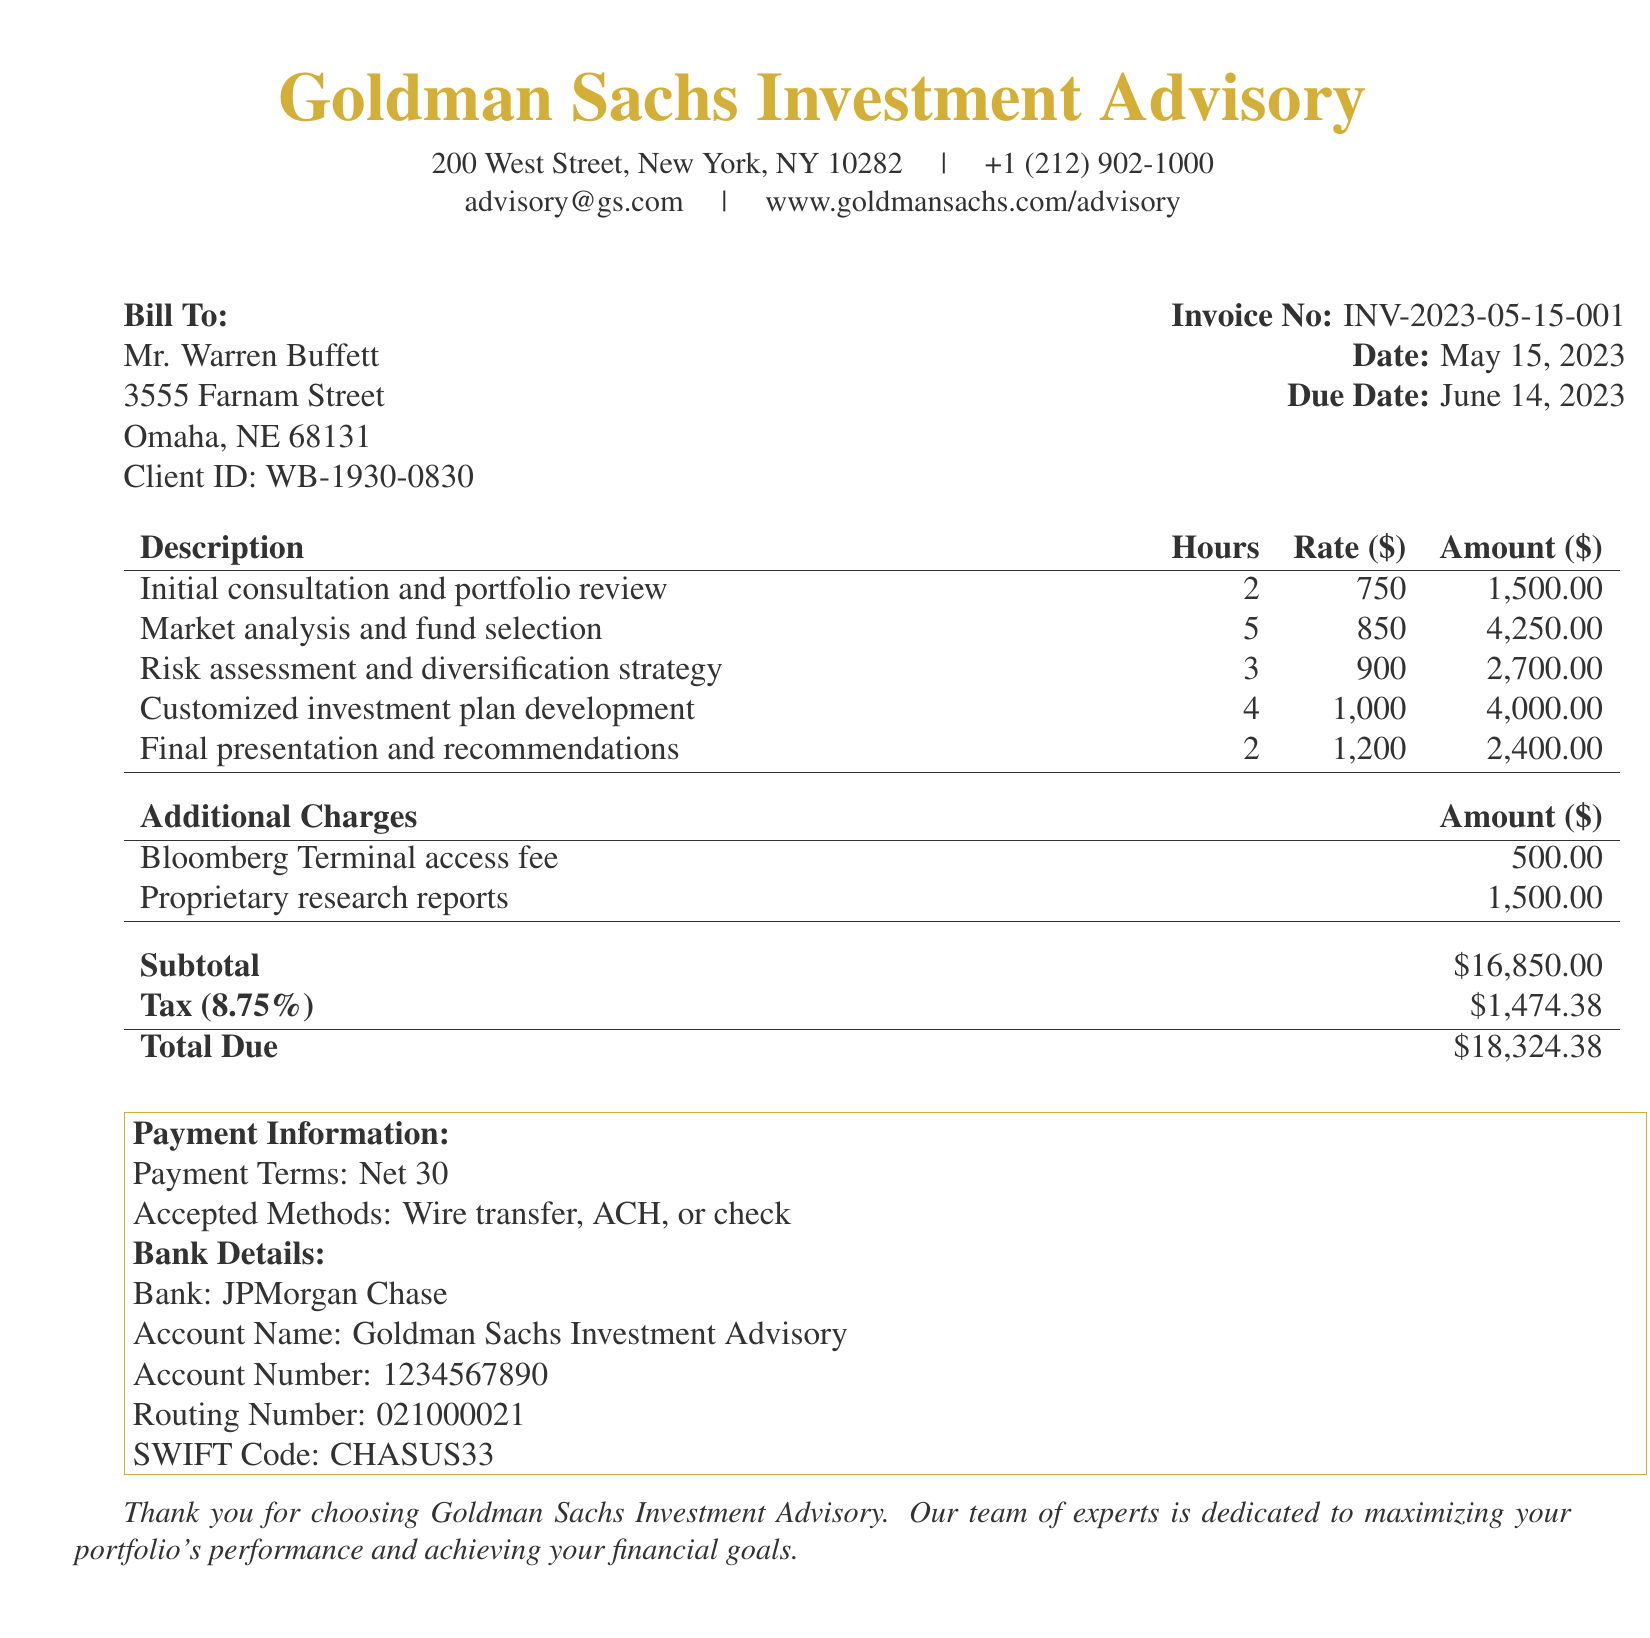What is the invoice number? The invoice number is listed in the document for reference, which is INV-2023-05-15-001.
Answer: INV-2023-05-15-001 Who is the bill addressed to? The document specifies the individual to whom the bill is sent, which is Mr. Warren Buffett.
Answer: Mr. Warren Buffett What is the due date of the invoice? The due date for payment is provided in the document, which is June 14, 2023.
Answer: June 14, 2023 How many hours were billed for market analysis and fund selection? The document indicates that 5 hours were charged for this service.
Answer: 5 What is the total amount due? The total amount due is the final figure calculated in the document, stated as $18,324.38.
Answer: $18,324.38 What is the hourly rate for customized investment plan development? The document specifies that the hourly rate for this service is $1,000.
Answer: $1,000 How much was charged for Bloomberg Terminal access? The document lists an additional charge of $500.
Answer: $500 What percentage tax was applied to the subtotal? The tax rate applied to the subtotal is given as 8.75%.
Answer: 8.75% How many different services are detailed in the invoice? The document lists five separate services provided.
Answer: 5 